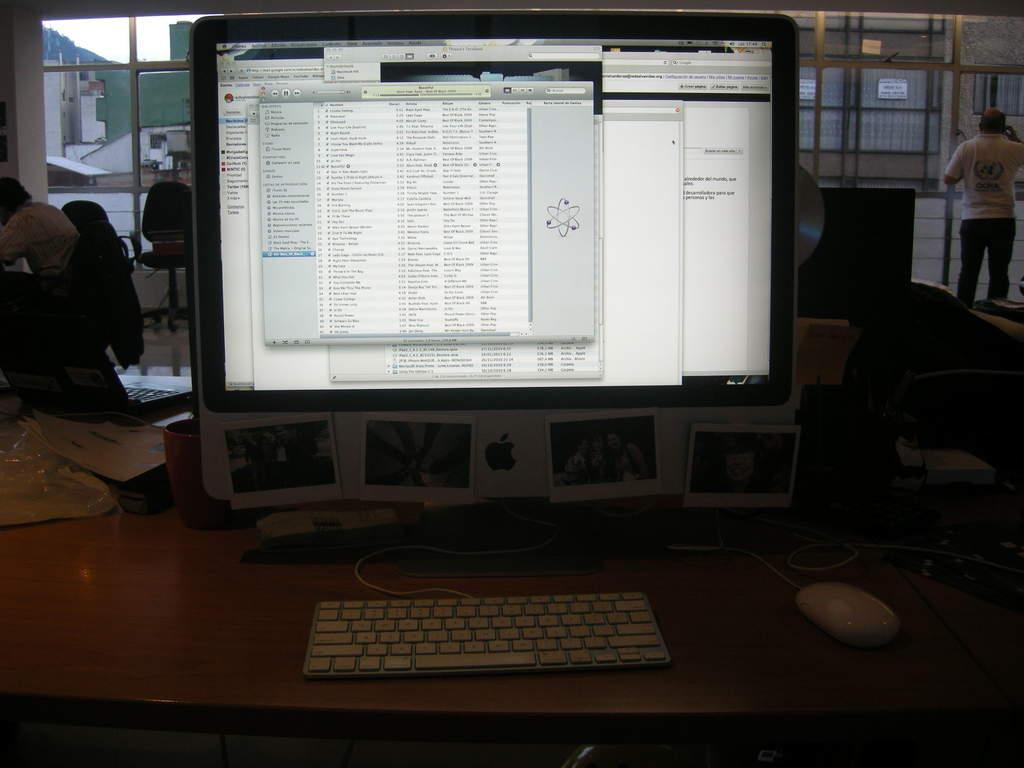What´s the brand of that desktop?
Keep it short and to the point. Apple. 